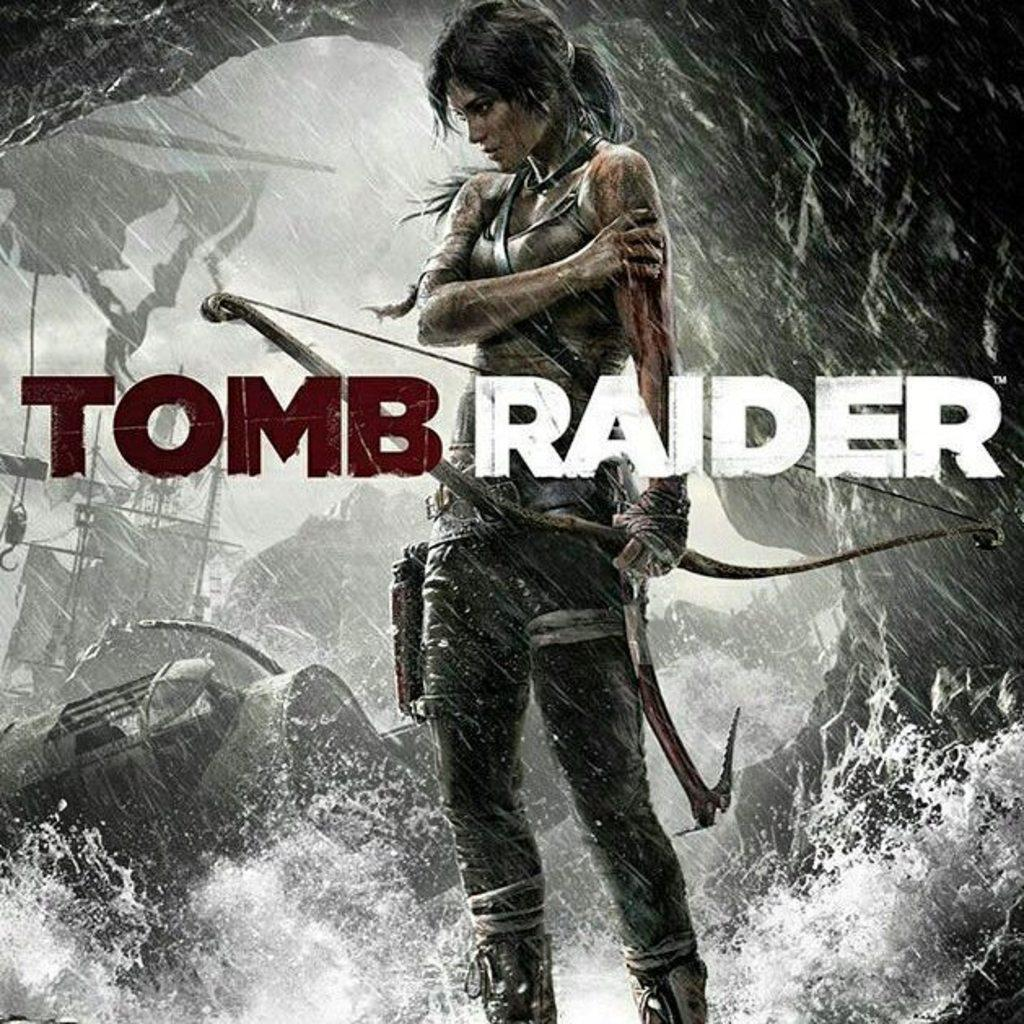<image>
Create a compact narrative representing the image presented. An intriguing poster for the film tomb raider. 